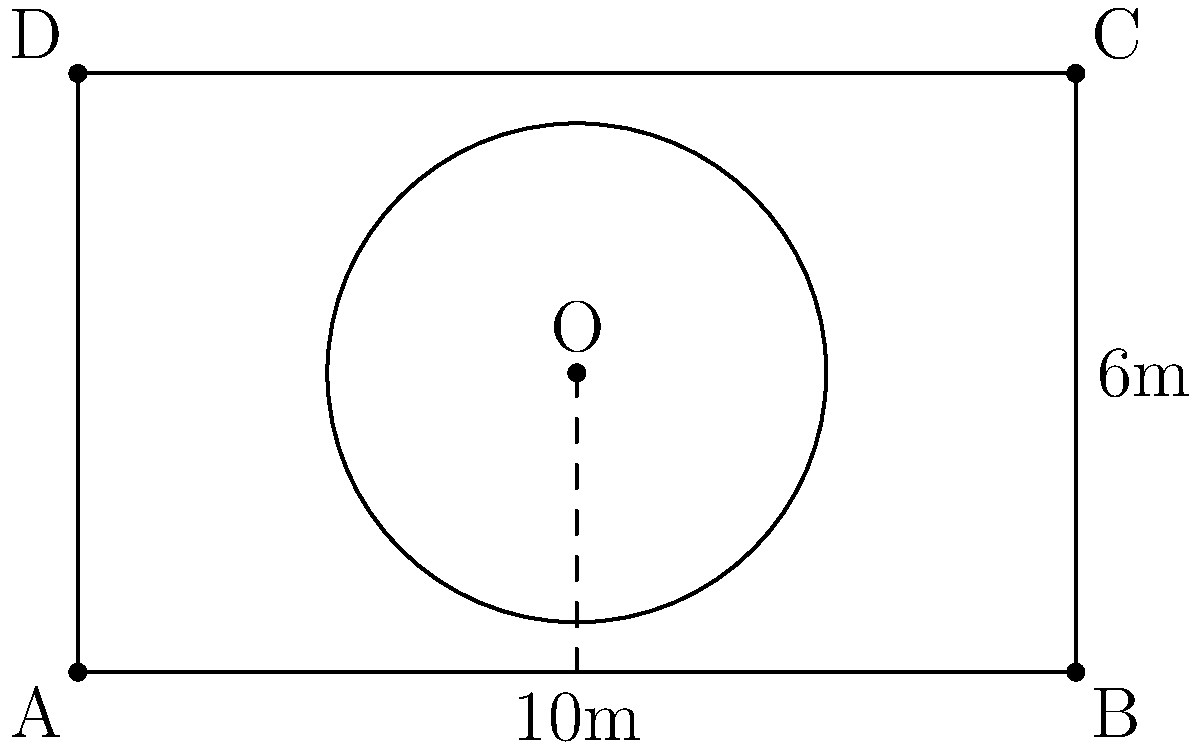You are designing a luxurious terrace for your penthouse in Pune. The rectangular terrace measures 10m by 6m, and you want to install a circular infinity pool. To maximize the view and aesthetic appeal, you decide to place the center of the pool at the exact center of the terrace. If the radius of the pool is 2.5m, what is the distance between the edge of the pool and the corner of the terrace? Let's approach this step-by-step:

1) First, we need to find the coordinates of the center of the terrace (O).
   Length of terrace = 10m, Width of terrace = 6m
   Center coordinates: $O(5, 3)$

2) The corners of the terrace are at:
   $A(0, 0)$, $B(10, 0)$, $C(10, 6)$, $D(0, 6)$

3) The radius of the pool is 2.5m.

4) To find the distance between the edge of the pool and a corner, we need to:
   a) Calculate the distance from the center to a corner
   b) Subtract the radius of the pool from this distance

5) Let's choose corner A(0, 0) for our calculation.

6) Distance from O to A:
   $OA = \sqrt{(x_O - x_A)^2 + (y_O - y_A)^2}$
   $OA = \sqrt{(5 - 0)^2 + (3 - 0)^2}$
   $OA = \sqrt{25 + 9} = \sqrt{34} \approx 5.83$ m

7) Distance from edge of pool to corner:
   Distance = $OA - r = \sqrt{34} - 2.5 \approx 3.33$ m

Therefore, the distance between the edge of the pool and the corner of the terrace is approximately 3.33 meters.
Answer: $\sqrt{34} - 2.5 \approx 3.33$ m 